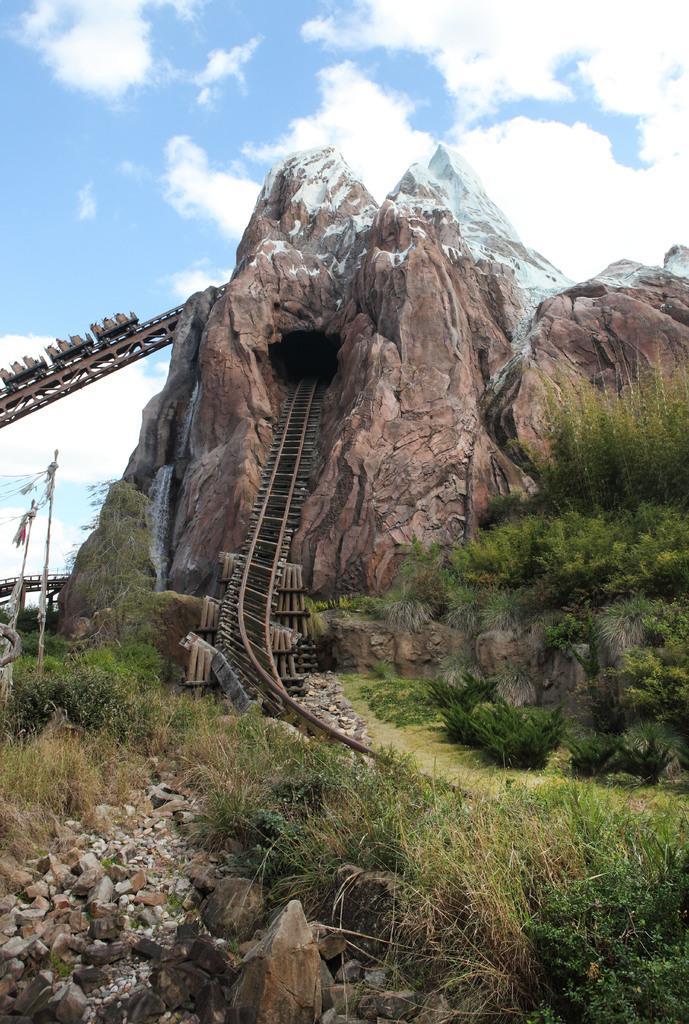Please provide a concise description of this image. In the foreground of the picture there are shrubs and stones. In the center of the picture there is a mountain. In the center to picture there is a railway track. Sky is sunny. 